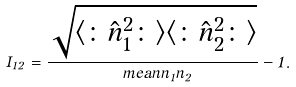<formula> <loc_0><loc_0><loc_500><loc_500>I _ { 1 2 } = \frac { \sqrt { \langle \colon \hat { n } _ { 1 } ^ { 2 } \colon \rangle \langle \colon \hat { n } _ { 2 } ^ { 2 } \colon \rangle } } { \ m e a n { \hat { n } _ { 1 } \hat { n } _ { 2 } } } - 1 .</formula> 